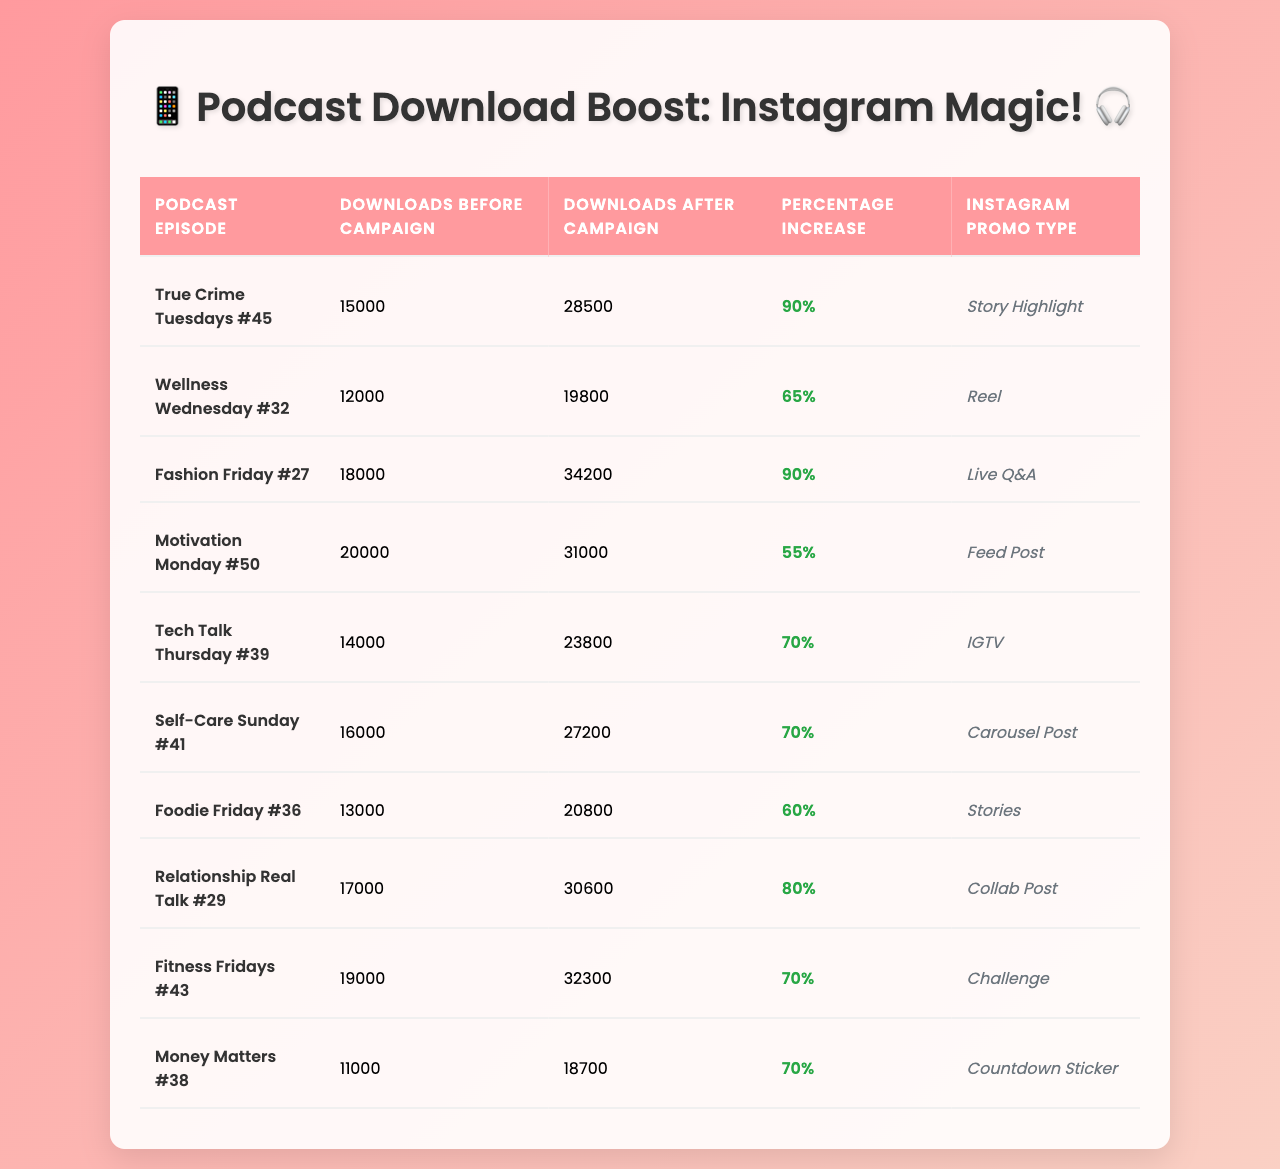What was the download increase for "True Crime Tuesdays #45"? The downloads increased from 15,000 to 28,500. The difference is 28,500 - 15,000 = 13,500 downloads.
Answer: 13,500 Which podcast episode saw the highest percentage increase in downloads? The highest percentage increase in downloads is seen in "True Crime Tuesdays #45" and "Fashion Friday #27," both with a 90% increase.
Answer: True Crime Tuesdays #45 and Fashion Friday #27 How many downloads did "Motivation Monday #50" have after the campaign? According to the table, "Motivation Monday #50" had 31,000 downloads after the Instagram promotion campaign.
Answer: 31,000 What is the average percentage increase of all podcast episodes listed? The percentage increases are: 90, 65, 90, 55, 70, 70, 60, 80, 70, and 70. Summing them gives 90 + 65 + 90 + 55 + 70 + 70 + 60 + 80 + 70 + 70 = 800. There are 10 episodes, so the average is 800 / 10 = 80%.
Answer: 80% Did "Money Matters #38" use a Story Highlight for its promotion? The promotional type listed for "Money Matters #38" is "Countdown Sticker," not a Story Highlight.
Answer: No How much more popular was "Fitness Fridays #43" compared to "Foodie Friday #36" after their respective campaigns? "Fitness Fridays #43" had 32,300 downloads after the campaign, while "Foodie Friday #36" had 20,800. The difference is 32,300 - 20,800 = 11,500 downloads.
Answer: 11,500 Which Instagram promo type yielded a 70% increase and which podcast episodes utilized it? The promo type yielding a 70% increase includes "IGTV" and "Carousel Post." The corresponding episodes are "Tech Talk Thursday #39" and "Self-Care Sunday #41."
Answer: IGTV and Carousel Post; Tech Talk Thursday #39 and Self-Care Sunday #41 Is there any podcast episode with downloads after the campaign exceeding 30,000? Yes, both "Fashion Friday #27" and "Fitness Fridays #43" had downloads exceeding 30,000 after their campaigns.
Answer: Yes What is the total number of downloads across all podcast episodes after the campaign? Calculating the total from all episodes listed after the campaign gives: 28,500 + 19,800 + 34,200 + 31,000 + 23,800 + 27,200 + 20,800 + 30,600 + 32,300 + 18,700 =  306,100 downloads.
Answer: 306,100 Which podcast episode had the lowest downloads before the campaign? "Money Matters #38" had the lowest downloads before the campaign with only 11,000 downloads.
Answer: Money Matters #38 